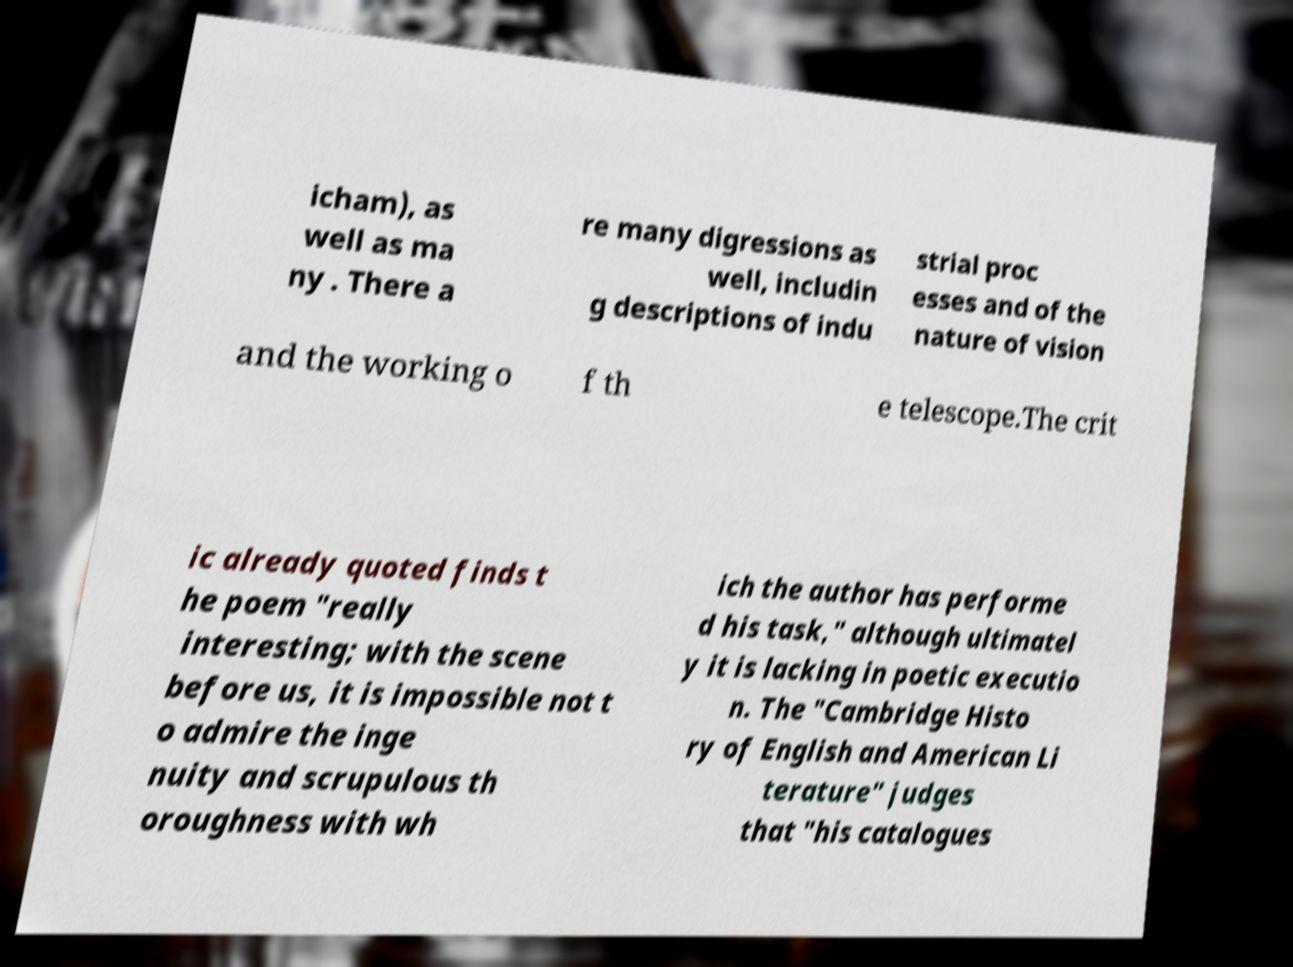What messages or text are displayed in this image? I need them in a readable, typed format. icham), as well as ma ny . There a re many digressions as well, includin g descriptions of indu strial proc esses and of the nature of vision and the working o f th e telescope.The crit ic already quoted finds t he poem "really interesting; with the scene before us, it is impossible not t o admire the inge nuity and scrupulous th oroughness with wh ich the author has performe d his task," although ultimatel y it is lacking in poetic executio n. The "Cambridge Histo ry of English and American Li terature" judges that "his catalogues 